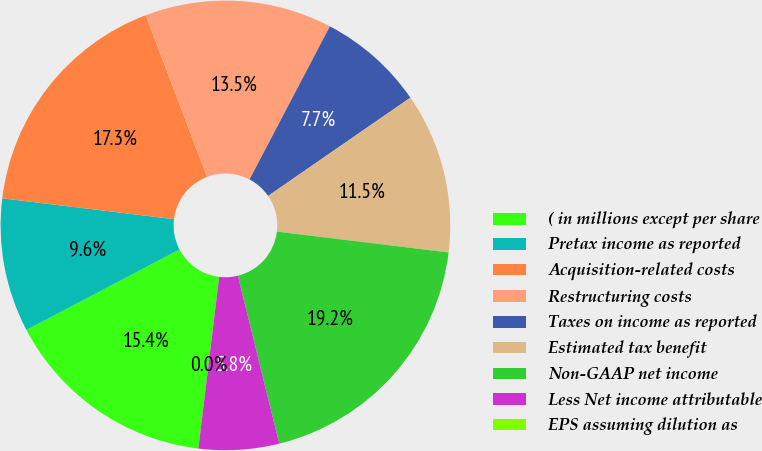Convert chart. <chart><loc_0><loc_0><loc_500><loc_500><pie_chart><fcel>( in millions except per share<fcel>Pretax income as reported<fcel>Acquisition-related costs<fcel>Restructuring costs<fcel>Taxes on income as reported<fcel>Estimated tax benefit<fcel>Non-GAAP net income<fcel>Less Net income attributable<fcel>EPS assuming dilution as<nl><fcel>15.38%<fcel>9.62%<fcel>17.31%<fcel>13.46%<fcel>7.69%<fcel>11.54%<fcel>19.23%<fcel>5.77%<fcel>0.0%<nl></chart> 